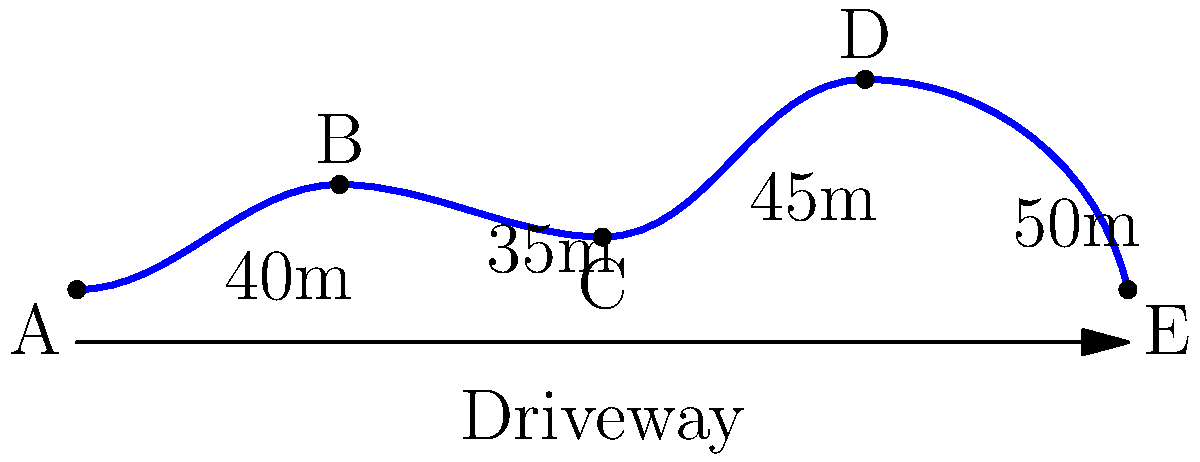Your new mansion boasts an impressive winding driveway that's the talk of the neighborhood. The driveway consists of four curved segments, as shown in the diagram. If the lengths of these segments are 40m, 35m, 45m, and 50m respectively, what is the total perimeter of your driveway? To calculate the perimeter of the winding driveway, we need to sum up the lengths of all segments:

1. First segment (A to B): 40m
2. Second segment (B to C): 35m
3. Third segment (C to D): 45m
4. Fourth segment (D to E): 50m

Total perimeter = 40m + 35m + 45m + 50m
                = $40 + 35 + 45 + 50$
                = $170$ meters

Therefore, the total perimeter of the winding driveway is 170 meters.
Answer: 170 meters 